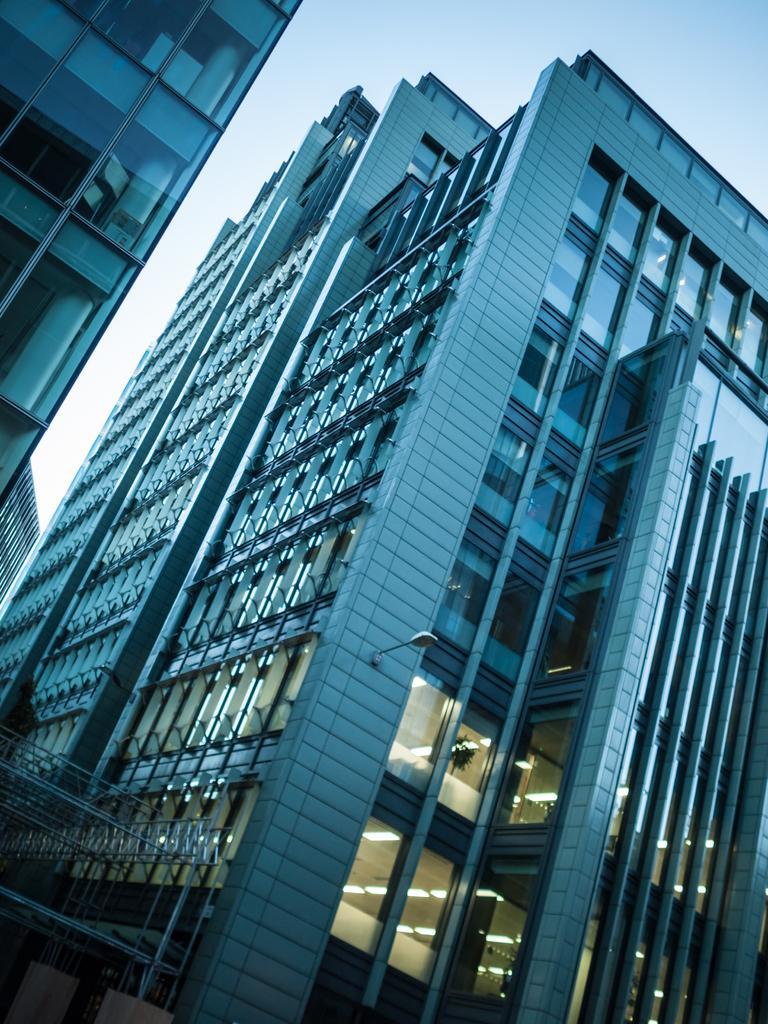Can you describe this image briefly? In this picture I can see buildings with glass doors, there are lights, iron rods, and in the background there is sky. 